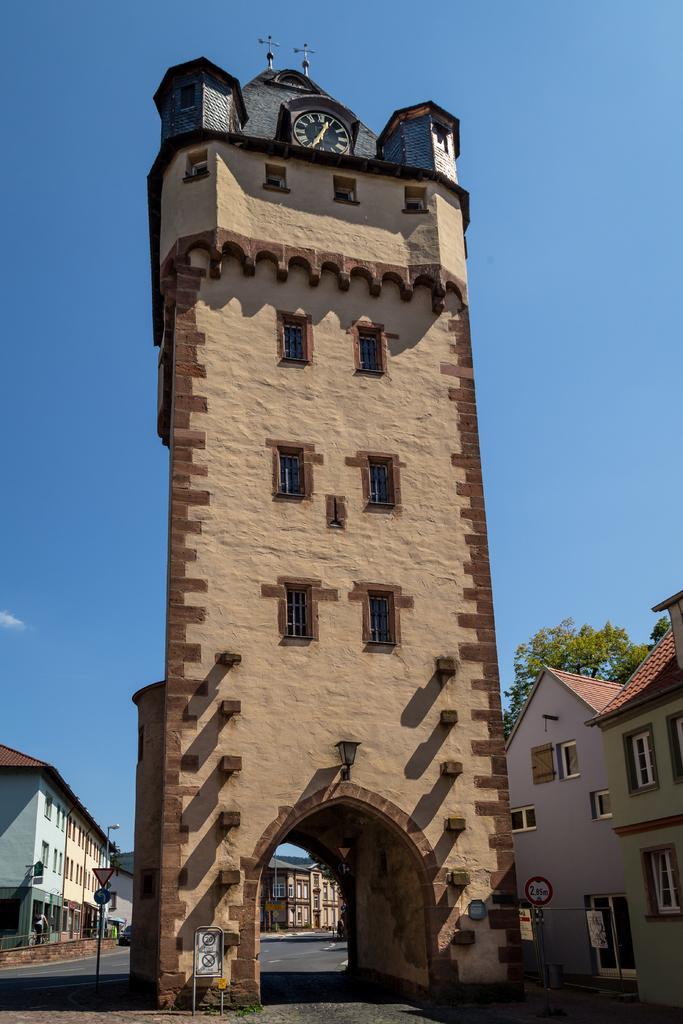How would you summarize this image in a sentence or two? In the picture I can see a clock tower and there are few buildings on either sides of it and there is a tree and a building in the background. 